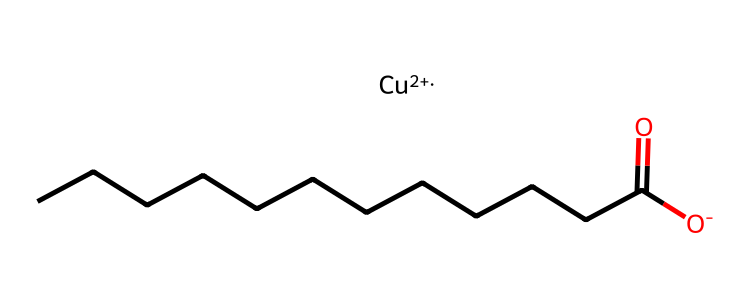What is the primary metal in copper naphthenate? The chemical structure contains the symbol "Cu", which represents copper.
Answer: copper How many carbon atoms are present in the carbon chain of this compound? The carbon chain has 11 carbon atoms in total, as inferred from the "CCCCCCCCCCC" segment.
Answer: 11 What type of bond is primarily responsible for the interaction of copper naphthenate with wood? Copper naphthenate primarily utilizes coordination bonds due to its copper ion complexing with wood components.
Answer: coordination bond What does the presence of a carboxylate group indicate about this chemical? The "C(=O)" portion in the structure suggests the presence of a carboxylate group, indicating potential reactivity and solubility characteristics.
Answer: carboxylate group How does the copper atom influence the fungicidal activity of this compound? The copper ion (Cu++) is known to exhibit antifungal properties, which is crucial for the preservation function of copper naphthenate.
Answer: antifungal properties 